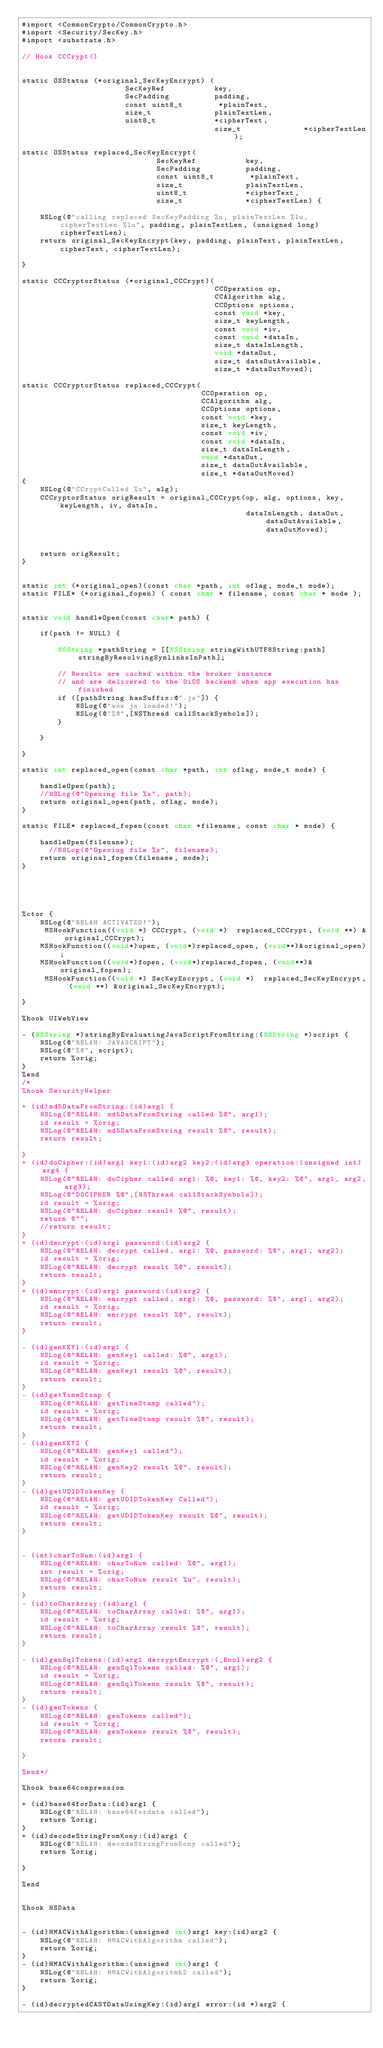<code> <loc_0><loc_0><loc_500><loc_500><_ObjectiveC_>#import <CommonCrypto/CommonCrypto.h>
#import <Security/SecKey.h>
#import <substrate.h>

// Hook CCCrypt()


static OSStatus (*original_SecKeyEncrypt) (
                       SecKeyRef           key,
                       SecPadding          padding,
                       const uint8_t        *plainText,
                       size_t              plainTextLen,
                       uint8_t             *cipherText,
                                           size_t              *cipherTextLen);

static OSStatus replaced_SecKeyEncrypt(
                              SecKeyRef           key,
                              SecPadding          padding,
                              const uint8_t        *plainText,
                              size_t              plainTextLen,
                              uint8_t             *cipherText,
                              size_t              *cipherTextLen) {
    
    NSLog(@"calling replaced SecKeyPadding %u, plainTextLen %lu, cipherTextLen %lu", padding, plainTextLen, (unsigned long)cipherTextLen);
    return original_SecKeyEncrypt(key, padding, plainText, plainTextLen, cipherText, cipherTextLen);
    
}

static CCCryptorStatus (*original_CCCrypt)(
                                           CCOperation op,
                                           CCAlgorithm alg,
                                           CCOptions options,
                                           const void *key,
                                           size_t keyLength,
                                           const void *iv,
                                           const void *dataIn,
                                           size_t dataInLength,
                                           void *dataOut,
                                           size_t dataOutAvailable,
                                           size_t *dataOutMoved);

static CCCryptorStatus replaced_CCCrypt(
                                        CCOperation op,
                                        CCAlgorithm alg,
                                        CCOptions options,
                                        const void *key,
                                        size_t keyLength,
                                        const void *iv,
                                        const void *dataIn,
                                        size_t dataInLength,
                                        void *dataOut,
                                        size_t dataOutAvailable,
                                        size_t *dataOutMoved)
{
    NSLog(@"CCryptCalled %u", alg);
    CCCryptorStatus origResult = original_CCCrypt(op, alg, options, key, keyLength, iv, dataIn,
                                                  dataInLength, dataOut, dataOutAvailable, dataOutMoved);
    
   
    return origResult;
}


static int (*original_open)(const char *path, int oflag, mode_t mode);
static FILE* (*original_fopen) ( const char * filename, const char * mode );


static void handleOpen(const char* path) {
    
    if(path != NULL) {
        
        NSString *pathString = [[NSString stringWithUTF8String:path] stringByResolvingSymlinksInPath];
        
        // Results are cached within the broker instance
        // and are delivered to the DiOS backend when app execution has finished
        if ([pathString hasSuffix:@".js"]) {
            NSLog(@"wow js loaded!");
            NSLog(@"%@",[NSThread callStackSymbols]);
        }
        
    }
    
}

static int replaced_open(const char *path, int oflag, mode_t mode) {
    
    handleOpen(path);
    //NSLog(@"Opening file %s", path);
    return original_open(path, oflag, mode);
}

static FILE* replaced_fopen(const char *filename, const char * mode) {
    
    handleOpen(filename);
      //NSLog(@"Opening file %s", filename);
    return original_fopen(filename, mode);
}





%ctor {
    NSLog(@"RELAH ACTIVATED!");
     MSHookFunction((void *) CCCrypt, (void *)  replaced_CCCrypt, (void **) &original_CCCrypt);
    MSHookFunction((void*)open, (void*)replaced_open, (void**)&original_open);
    MSHookFunction((void*)fopen, (void*)replaced_fopen, (void**)&original_fopen);
     MSHookFunction((void *) SecKeyEncrypt, (void *)  replaced_SecKeyEncrypt, (void **) &original_SecKeyEncrypt);
    
}

%hook UIWebView

- (NSString *)stringByEvaluatingJavaScriptFromString:(NSString *)script {
    NSLog(@"RELAH: JAVASCRIPT");
    NSLog(@"%@", script);
    return %orig;
}
%end
/*
%hook SecurityHelper

+ (id)md5DataFromString:(id)arg1 {
    NSLog(@"RELAH: md5DataFromString called %@", arg1);
    id result = %orig;
    NSLog(@"RELAH: md5DataFromString result %@", result);
    return result;

}
+ (id)doCipher:(id)arg1 key1:(id)arg2 key2:(id)arg3 operation:(unsigned int)arg4 {
    NSLog(@"RELAH: doCipher called arg1: %@, key1: %@, key2: %@", arg1, arg2, arg3);
    NSLog(@"DOCIPHER %@",[NSThread callStackSymbols]);
    id result = %orig;
    NSLog(@"RELAH: doCipher result %@", result);
    return @"";
    //return result;
}
+ (id)decrypt:(id)arg1 password:(id)arg2 {
    NSLog(@"RELAH: decrypt called, arg1: %@, password: %@", arg1, arg2);
    id result = %orig;
    NSLog(@"RELAH: decrypt result %@", result);
    return result;
}
+ (id)encrypt:(id)arg1 password:(id)arg2 {
    NSLog(@"RELAH: encrypt called, arg1: %@, password: %@", arg1, arg2);
    id result = %orig;
    NSLog(@"RELAH: encrypt result %@", result);
    return result;
}

- (id)genKEY1:(id)arg1 {
    NSLog(@"RELAH: genKey1 called: %@", arg1);
    id result = %orig;
    NSLog(@"RELAH: genKey1 result %@", result);
    return result;
}
- (id)getTimeStamp {
    NSLog(@"RELAH: getTimeStamp called");
    id result = %orig;
    NSLog(@"RELAH: getTimeStamp result %@", result);
    return result;
}
- (id)genKEY2 {
    NSLog(@"RELAH: genKey1 called");
    id result = %orig;
    NSLog(@"RELAH: genKey2 result %@", result);
    return result;
}
- (id)getUDIDTokenKey {
    NSLog(@"RELAH: getUDIDTokenKey Called");
    id result = %orig;
    NSLog(@"RELAH: getUDIDTokenKey result %@", result);
    return result;
}


- (int)charToNum:(id)arg1 {
    NSLog(@"RELAH: charToNum called: %@", arg1);
    int result = %orig;
    NSLog(@"RELAH: charToNum result %u", result);
    return result;
}
- (id)toCharArray:(id)arg1 {
    NSLog(@"RELAH: toCharArray called: %@", arg1);
    id result = %orig;
    NSLog(@"RELAH: toCharArray result %@", result);
    return result;
}

- (id)genSqlTokens:(id)arg1 decryptEncrypt:(_Bool)arg2 {
    NSLog(@"RELAH: genSqlTokens called: %@", arg1);
    id result = %orig;
    NSLog(@"RELAH: genSqlTokens result %@", result);
    return result;
}
- (id)genTokens {
    NSLog(@"RELAH: genTokens called");
    id result = %orig;
    NSLog(@"RELAH: genTokens result %@", result);
    return result;
    
}

%end*/

%hook base64compression

+ (id)base64forData:(id)arg1 {
    NSLog(@"RELAH: base64fordata called");
    return %orig;
}
+ (id)decodeStringFromKony:(id)arg1 {
    NSLog(@"RELAH: decodeStringFromKony called");
    return %orig;
    
}

%end


%hook NSData


- (id)HMACWithAlgorithm:(unsigned int)arg1 key:(id)arg2 {
    NSLog(@"RELAH: HMACWithAlgorithm called");
    return %orig;
}
- (id)HMACWithAlgorithm:(unsigned int)arg1 {
    NSLog(@"RELAH: HMACWithAlgoritmh2 called");
    return %orig;
}

- (id)decryptedCASTDataUsingKey:(id)arg1 error:(id *)arg2 {</code> 